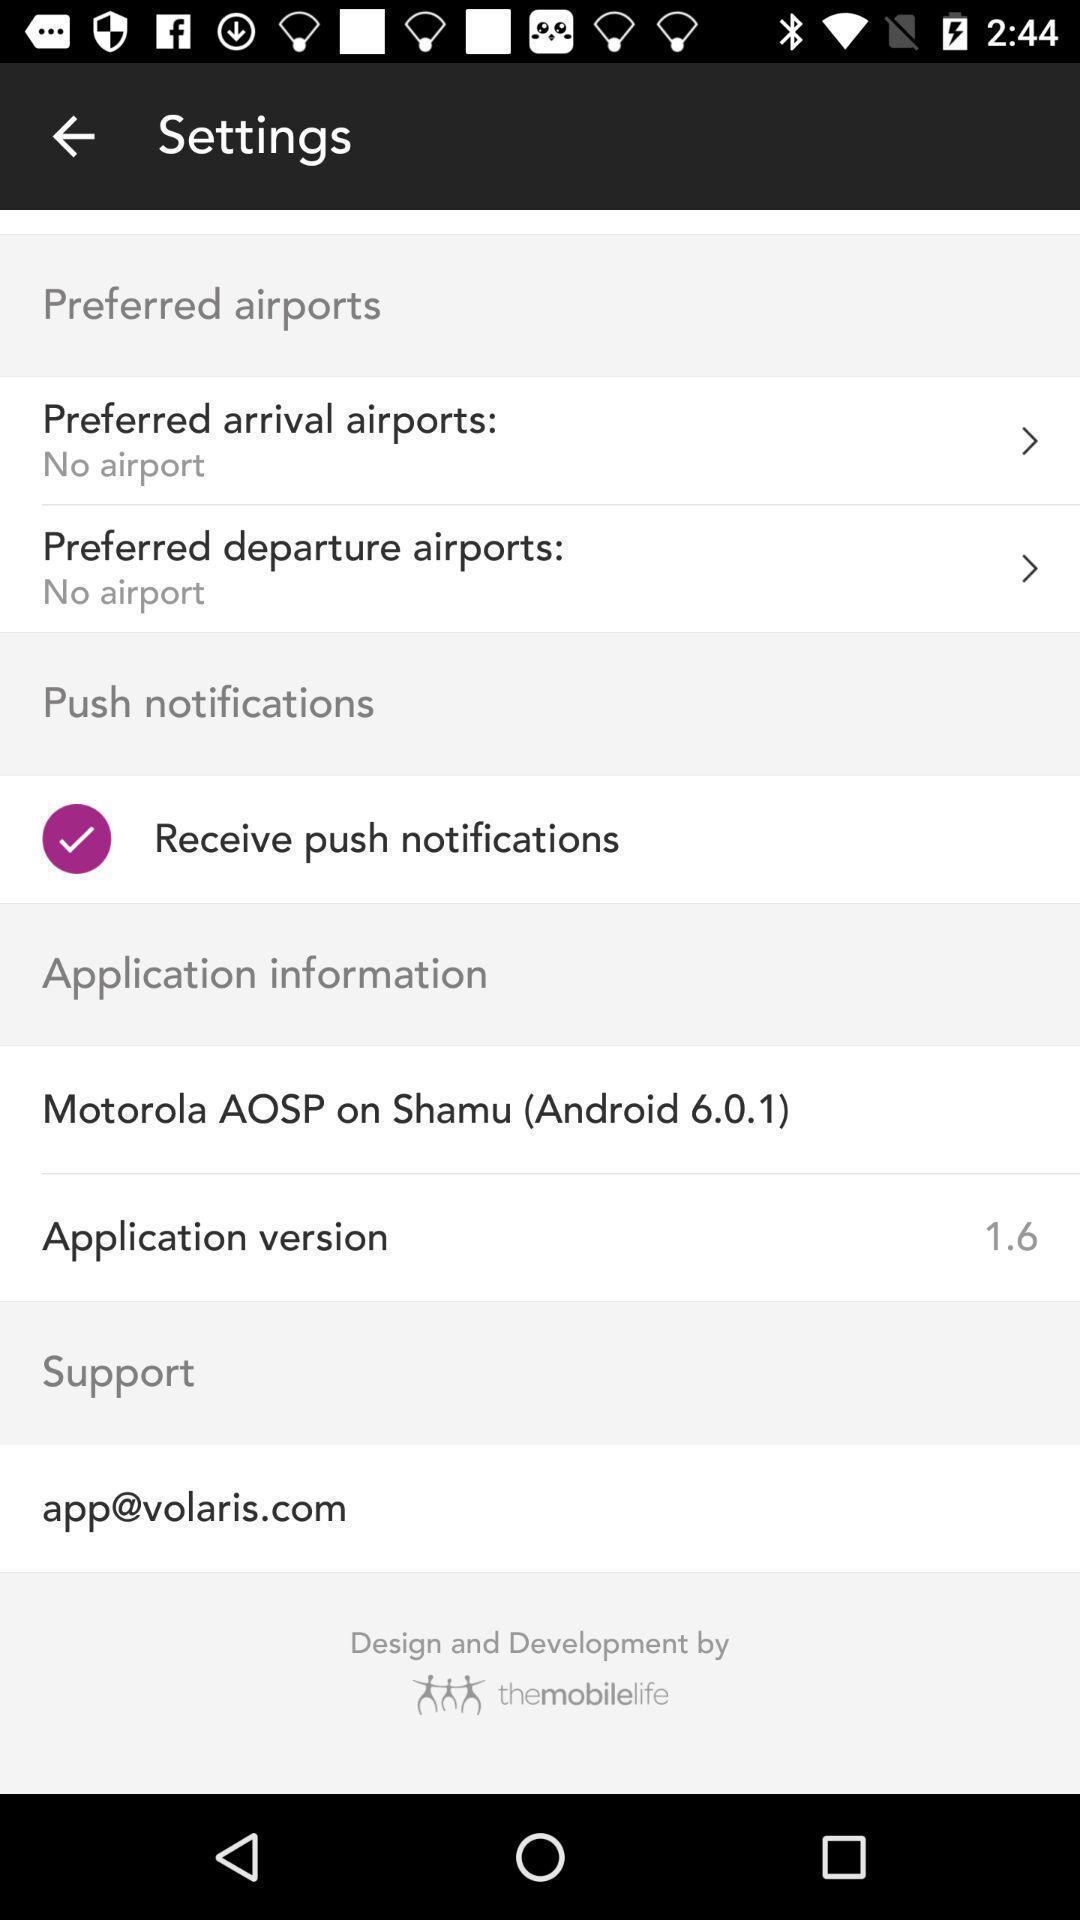Summarize the information in this screenshot. Settings page of a travel app. 